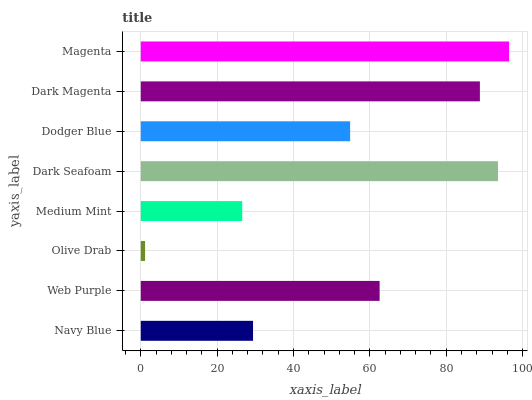Is Olive Drab the minimum?
Answer yes or no. Yes. Is Magenta the maximum?
Answer yes or no. Yes. Is Web Purple the minimum?
Answer yes or no. No. Is Web Purple the maximum?
Answer yes or no. No. Is Web Purple greater than Navy Blue?
Answer yes or no. Yes. Is Navy Blue less than Web Purple?
Answer yes or no. Yes. Is Navy Blue greater than Web Purple?
Answer yes or no. No. Is Web Purple less than Navy Blue?
Answer yes or no. No. Is Web Purple the high median?
Answer yes or no. Yes. Is Dodger Blue the low median?
Answer yes or no. Yes. Is Navy Blue the high median?
Answer yes or no. No. Is Olive Drab the low median?
Answer yes or no. No. 